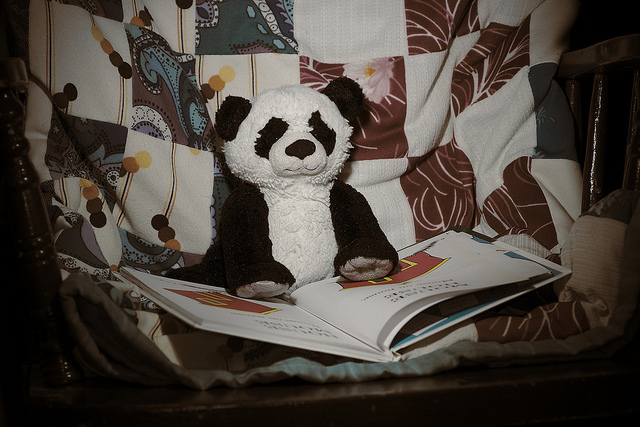<image>What is the name of the book? The name of the book is unknown as it could be 'teddy', 'panda bear', 'red barn', 'panda book', 'cinderella', 'cool', 'goodnight moon', or 'red house'. What is the name of the book? I don't know the name of the book. It can be seen as 'teddy', 'panda bear', 'red barn', 'panda book', 'cinderella', 'cool', 'goodnight moon', 'red house', or "can't see". 